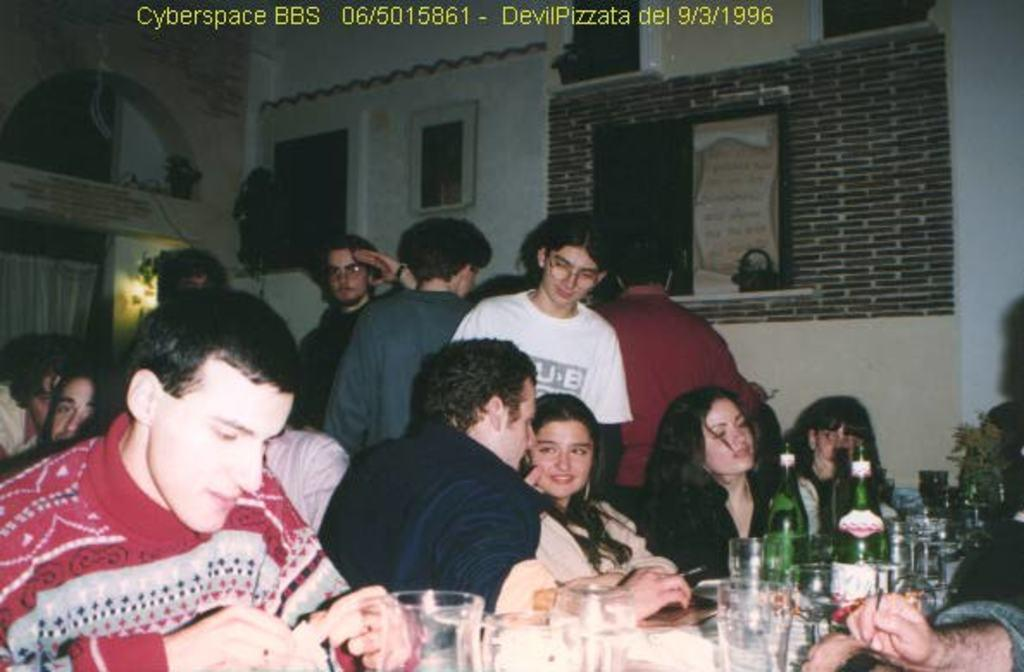What are the people in the image doing? There is a group of people sitting in the image, and another group of people standing behind them. What is on the table in the image? The table is full of wine glasses and wine bottles. Can you describe the arrangement of the people in the image? There is a group of people sitting, and a group of people standing behind them. What might be the purpose of the table with wine glasses and bottles in the image? The table with wine glasses and bottles suggests that the people in the image are having a gathering or celebration. What type of health advice can be given to the manager in the image? There is no manager present in the image, and therefore no health advice can be given to them. 